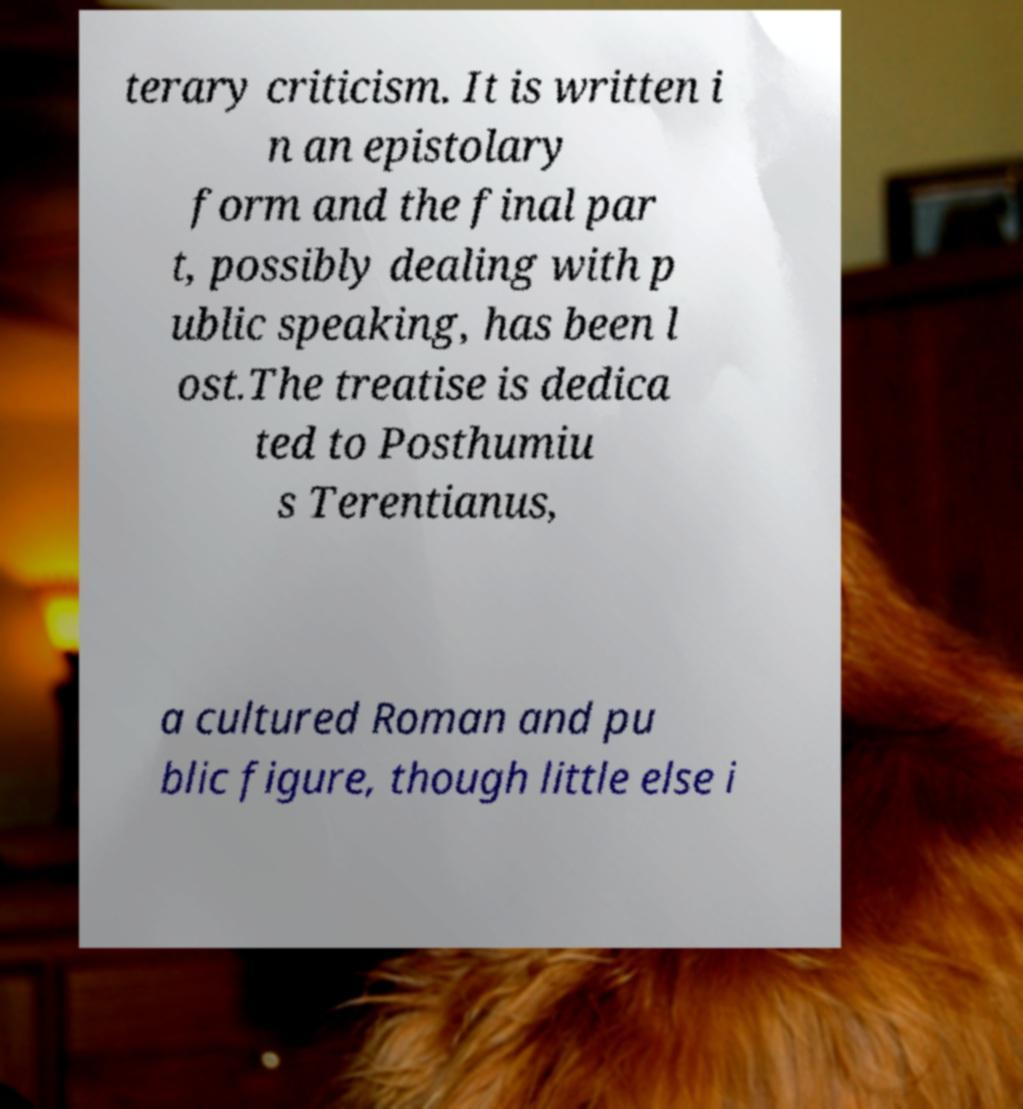Please read and relay the text visible in this image. What does it say? terary criticism. It is written i n an epistolary form and the final par t, possibly dealing with p ublic speaking, has been l ost.The treatise is dedica ted to Posthumiu s Terentianus, a cultured Roman and pu blic figure, though little else i 